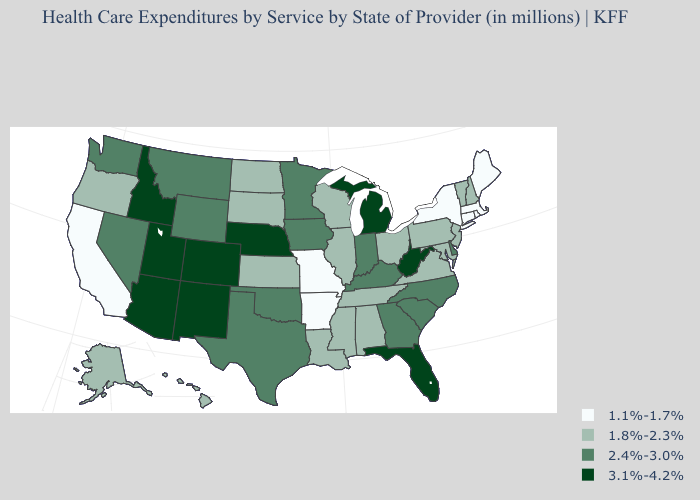Which states have the lowest value in the USA?
Be succinct. Arkansas, California, Connecticut, Maine, Massachusetts, Missouri, New York, Rhode Island. Which states have the lowest value in the South?
Keep it brief. Arkansas. Name the states that have a value in the range 2.4%-3.0%?
Keep it brief. Delaware, Georgia, Indiana, Iowa, Kentucky, Minnesota, Montana, Nevada, North Carolina, Oklahoma, South Carolina, Texas, Washington, Wyoming. Name the states that have a value in the range 2.4%-3.0%?
Write a very short answer. Delaware, Georgia, Indiana, Iowa, Kentucky, Minnesota, Montana, Nevada, North Carolina, Oklahoma, South Carolina, Texas, Washington, Wyoming. Which states hav the highest value in the MidWest?
Concise answer only. Michigan, Nebraska. Name the states that have a value in the range 1.1%-1.7%?
Be succinct. Arkansas, California, Connecticut, Maine, Massachusetts, Missouri, New York, Rhode Island. What is the value of Louisiana?
Concise answer only. 1.8%-2.3%. What is the value of Texas?
Short answer required. 2.4%-3.0%. Which states have the highest value in the USA?
Write a very short answer. Arizona, Colorado, Florida, Idaho, Michigan, Nebraska, New Mexico, Utah, West Virginia. Which states have the lowest value in the USA?
Answer briefly. Arkansas, California, Connecticut, Maine, Massachusetts, Missouri, New York, Rhode Island. What is the value of New Mexico?
Be succinct. 3.1%-4.2%. What is the lowest value in states that border North Dakota?
Be succinct. 1.8%-2.3%. Which states have the lowest value in the USA?
Be succinct. Arkansas, California, Connecticut, Maine, Massachusetts, Missouri, New York, Rhode Island. Does Arkansas have the highest value in the USA?
Short answer required. No. Name the states that have a value in the range 1.1%-1.7%?
Be succinct. Arkansas, California, Connecticut, Maine, Massachusetts, Missouri, New York, Rhode Island. 